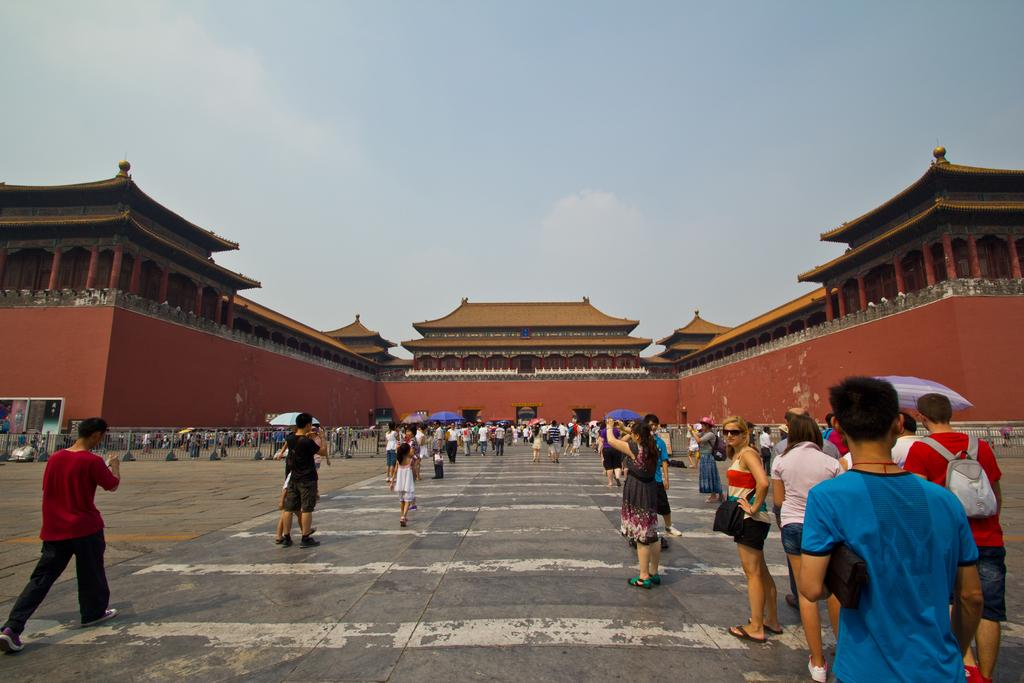What are the people in the image doing? The persons in the image are taking photographs. What can be seen in the background of the image? There is a Buddha temple in the background. What architectural feature is visible at the top of the image? Roof tiles are visible on the top of the image. How many bikes are parked near the persons in the image? There is no mention of bikes in the image, so it is impossible to determine how many might be parked nearby. --- Facts: 1. There is a person holding a book. 2. The person is sitting on a chair. 3. There is a table in front of the person. 4. The table has a cup on it. 5. The background of the image is a room. Absurd Topics: parrot, ocean, trampoline Conversation: What is the person in the image holding? The person is holding a book. What is the person sitting on in the image? The person is sitting on a chair. What object is in front of the person? There is a table in front of the person. What is on the table in the image? The table has a cup on it. What can be seen in the background of the image? The background of the image is a room. Reasoning: Let's think step by step in order to produce the conversation. We start by identifying the main subject in the image, which is the person holding a book. Then, we describe the person's position and the objects around them, such as the chair, table, and cup. Finally, we mention the background of the image, which is a room. Absurd Question/Answer: Can you see a parrot flying over the ocean in the image? There is no mention of a parrot or the ocean in the image, so it is impossible to determine if a parrot is flying over the ocean. 